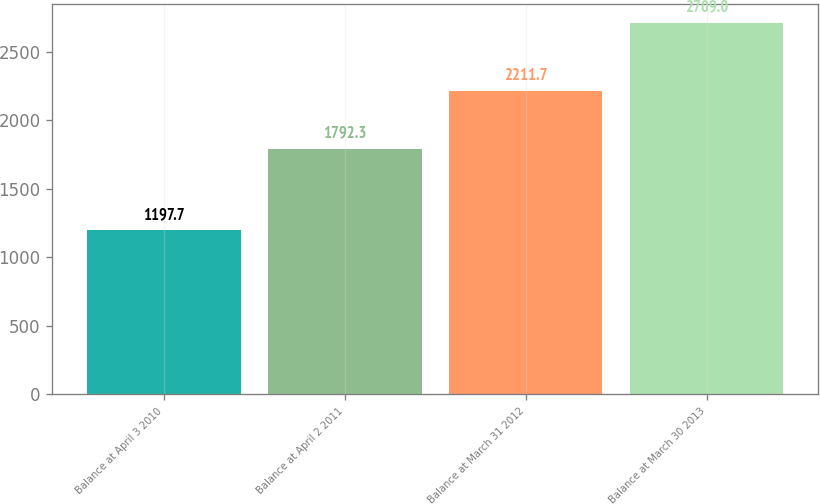Convert chart. <chart><loc_0><loc_0><loc_500><loc_500><bar_chart><fcel>Balance at April 3 2010<fcel>Balance at April 2 2011<fcel>Balance at March 31 2012<fcel>Balance at March 30 2013<nl><fcel>1197.7<fcel>1792.3<fcel>2211.7<fcel>2709<nl></chart> 